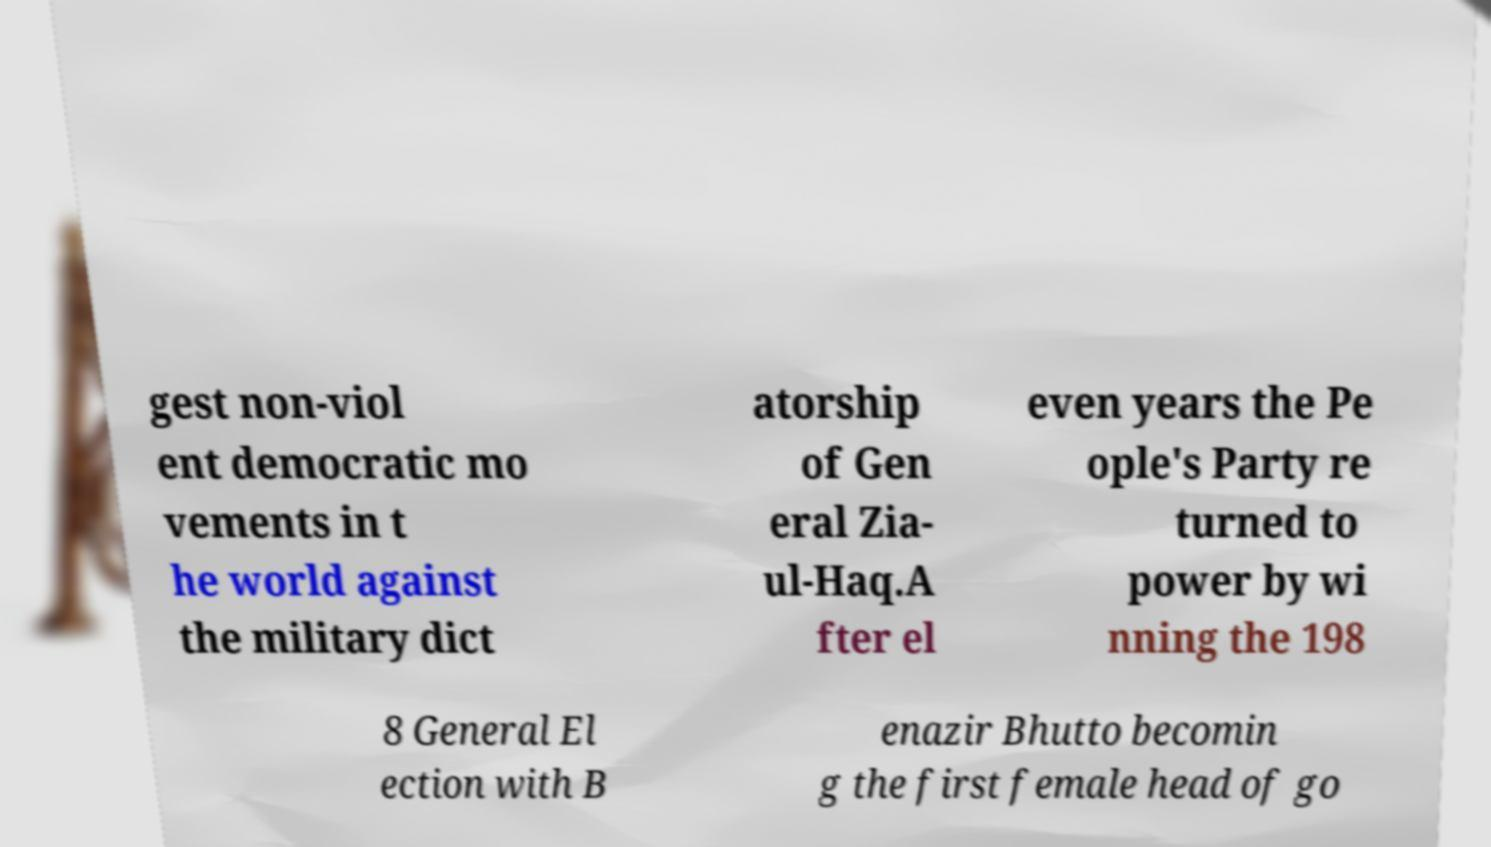I need the written content from this picture converted into text. Can you do that? gest non-viol ent democratic mo vements in t he world against the military dict atorship of Gen eral Zia- ul-Haq.A fter el even years the Pe ople's Party re turned to power by wi nning the 198 8 General El ection with B enazir Bhutto becomin g the first female head of go 